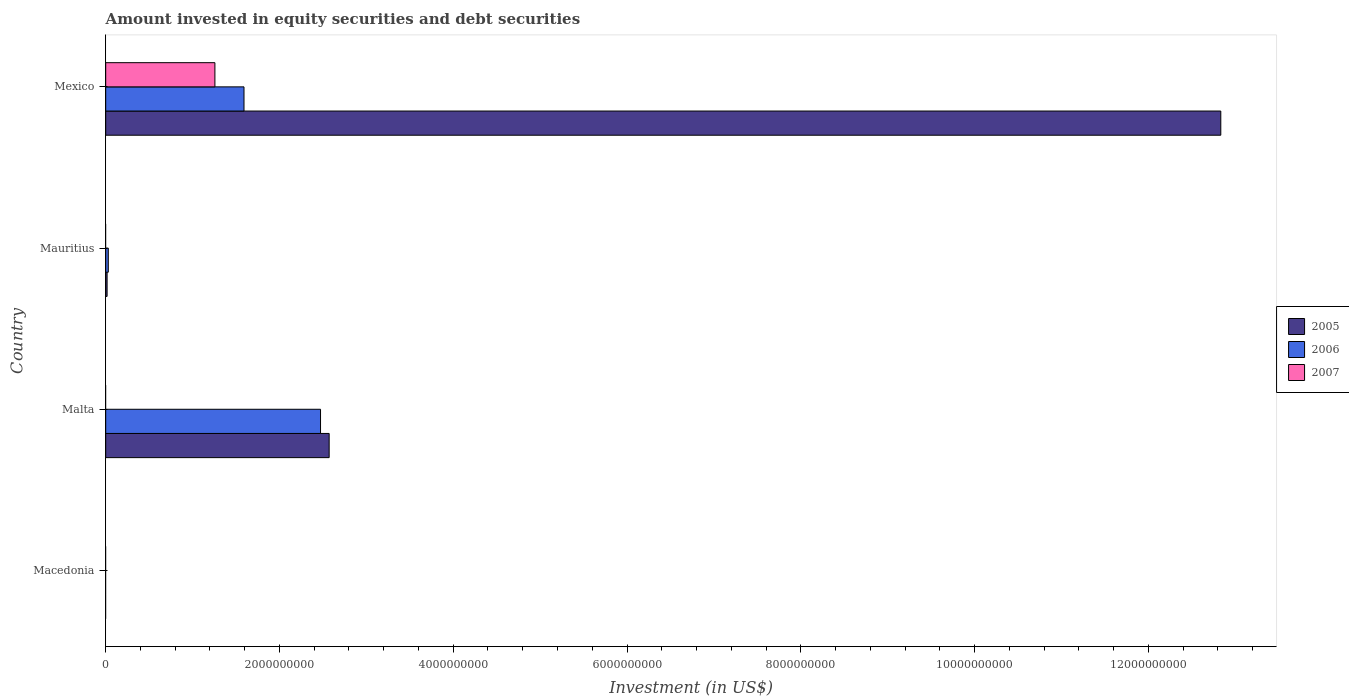Are the number of bars per tick equal to the number of legend labels?
Your response must be concise. No. Are the number of bars on each tick of the Y-axis equal?
Offer a terse response. No. How many bars are there on the 4th tick from the bottom?
Keep it short and to the point. 3. What is the label of the 4th group of bars from the top?
Offer a very short reply. Macedonia. What is the amount invested in equity securities and debt securities in 2007 in Mauritius?
Give a very brief answer. 0. Across all countries, what is the maximum amount invested in equity securities and debt securities in 2005?
Your response must be concise. 1.28e+1. In which country was the amount invested in equity securities and debt securities in 2007 maximum?
Your answer should be very brief. Mexico. What is the total amount invested in equity securities and debt securities in 2005 in the graph?
Ensure brevity in your answer.  1.54e+1. What is the difference between the amount invested in equity securities and debt securities in 2005 in Mauritius and that in Mexico?
Offer a very short reply. -1.28e+1. What is the difference between the amount invested in equity securities and debt securities in 2007 in Mauritius and the amount invested in equity securities and debt securities in 2006 in Macedonia?
Provide a short and direct response. 0. What is the average amount invested in equity securities and debt securities in 2007 per country?
Your response must be concise. 3.14e+08. What is the ratio of the amount invested in equity securities and debt securities in 2005 in Malta to that in Mexico?
Provide a short and direct response. 0.2. What is the difference between the highest and the second highest amount invested in equity securities and debt securities in 2006?
Ensure brevity in your answer.  8.81e+08. What is the difference between the highest and the lowest amount invested in equity securities and debt securities in 2006?
Give a very brief answer. 2.47e+09. In how many countries, is the amount invested in equity securities and debt securities in 2006 greater than the average amount invested in equity securities and debt securities in 2006 taken over all countries?
Provide a short and direct response. 2. Is the sum of the amount invested in equity securities and debt securities in 2006 in Malta and Mexico greater than the maximum amount invested in equity securities and debt securities in 2007 across all countries?
Keep it short and to the point. Yes. Is it the case that in every country, the sum of the amount invested in equity securities and debt securities in 2007 and amount invested in equity securities and debt securities in 2005 is greater than the amount invested in equity securities and debt securities in 2006?
Give a very brief answer. No. How many countries are there in the graph?
Make the answer very short. 4. What is the difference between two consecutive major ticks on the X-axis?
Offer a terse response. 2.00e+09. Are the values on the major ticks of X-axis written in scientific E-notation?
Your response must be concise. No. Does the graph contain any zero values?
Provide a succinct answer. Yes. How are the legend labels stacked?
Provide a succinct answer. Vertical. What is the title of the graph?
Your answer should be very brief. Amount invested in equity securities and debt securities. What is the label or title of the X-axis?
Provide a short and direct response. Investment (in US$). What is the Investment (in US$) of 2005 in Macedonia?
Your answer should be compact. 0. What is the Investment (in US$) of 2006 in Macedonia?
Ensure brevity in your answer.  0. What is the Investment (in US$) in 2007 in Macedonia?
Your response must be concise. 0. What is the Investment (in US$) in 2005 in Malta?
Ensure brevity in your answer.  2.57e+09. What is the Investment (in US$) of 2006 in Malta?
Offer a very short reply. 2.47e+09. What is the Investment (in US$) in 2007 in Malta?
Provide a succinct answer. 0. What is the Investment (in US$) in 2005 in Mauritius?
Your answer should be compact. 1.62e+07. What is the Investment (in US$) in 2006 in Mauritius?
Your answer should be compact. 2.99e+07. What is the Investment (in US$) in 2005 in Mexico?
Your answer should be compact. 1.28e+1. What is the Investment (in US$) in 2006 in Mexico?
Your answer should be very brief. 1.59e+09. What is the Investment (in US$) of 2007 in Mexico?
Ensure brevity in your answer.  1.26e+09. Across all countries, what is the maximum Investment (in US$) of 2005?
Provide a short and direct response. 1.28e+1. Across all countries, what is the maximum Investment (in US$) in 2006?
Provide a succinct answer. 2.47e+09. Across all countries, what is the maximum Investment (in US$) of 2007?
Your answer should be compact. 1.26e+09. Across all countries, what is the minimum Investment (in US$) in 2006?
Provide a short and direct response. 0. Across all countries, what is the minimum Investment (in US$) in 2007?
Your response must be concise. 0. What is the total Investment (in US$) in 2005 in the graph?
Your answer should be very brief. 1.54e+1. What is the total Investment (in US$) in 2006 in the graph?
Ensure brevity in your answer.  4.09e+09. What is the total Investment (in US$) in 2007 in the graph?
Ensure brevity in your answer.  1.26e+09. What is the difference between the Investment (in US$) of 2005 in Malta and that in Mauritius?
Provide a short and direct response. 2.56e+09. What is the difference between the Investment (in US$) of 2006 in Malta and that in Mauritius?
Ensure brevity in your answer.  2.44e+09. What is the difference between the Investment (in US$) in 2005 in Malta and that in Mexico?
Your answer should be compact. -1.03e+1. What is the difference between the Investment (in US$) in 2006 in Malta and that in Mexico?
Make the answer very short. 8.81e+08. What is the difference between the Investment (in US$) in 2005 in Mauritius and that in Mexico?
Provide a short and direct response. -1.28e+1. What is the difference between the Investment (in US$) in 2006 in Mauritius and that in Mexico?
Provide a succinct answer. -1.56e+09. What is the difference between the Investment (in US$) of 2005 in Malta and the Investment (in US$) of 2006 in Mauritius?
Offer a terse response. 2.54e+09. What is the difference between the Investment (in US$) of 2005 in Malta and the Investment (in US$) of 2006 in Mexico?
Make the answer very short. 9.80e+08. What is the difference between the Investment (in US$) in 2005 in Malta and the Investment (in US$) in 2007 in Mexico?
Give a very brief answer. 1.32e+09. What is the difference between the Investment (in US$) in 2006 in Malta and the Investment (in US$) in 2007 in Mexico?
Offer a very short reply. 1.22e+09. What is the difference between the Investment (in US$) of 2005 in Mauritius and the Investment (in US$) of 2006 in Mexico?
Ensure brevity in your answer.  -1.58e+09. What is the difference between the Investment (in US$) in 2005 in Mauritius and the Investment (in US$) in 2007 in Mexico?
Offer a terse response. -1.24e+09. What is the difference between the Investment (in US$) in 2006 in Mauritius and the Investment (in US$) in 2007 in Mexico?
Your answer should be very brief. -1.23e+09. What is the average Investment (in US$) of 2005 per country?
Offer a very short reply. 3.86e+09. What is the average Investment (in US$) of 2006 per country?
Make the answer very short. 1.02e+09. What is the average Investment (in US$) in 2007 per country?
Offer a terse response. 3.14e+08. What is the difference between the Investment (in US$) in 2005 and Investment (in US$) in 2006 in Malta?
Your answer should be compact. 9.93e+07. What is the difference between the Investment (in US$) of 2005 and Investment (in US$) of 2006 in Mauritius?
Keep it short and to the point. -1.38e+07. What is the difference between the Investment (in US$) of 2005 and Investment (in US$) of 2006 in Mexico?
Offer a very short reply. 1.12e+1. What is the difference between the Investment (in US$) in 2005 and Investment (in US$) in 2007 in Mexico?
Your answer should be compact. 1.16e+1. What is the difference between the Investment (in US$) in 2006 and Investment (in US$) in 2007 in Mexico?
Your response must be concise. 3.35e+08. What is the ratio of the Investment (in US$) of 2005 in Malta to that in Mauritius?
Offer a very short reply. 159.21. What is the ratio of the Investment (in US$) in 2006 in Malta to that in Mauritius?
Offer a very short reply. 82.62. What is the ratio of the Investment (in US$) in 2005 in Malta to that in Mexico?
Ensure brevity in your answer.  0.2. What is the ratio of the Investment (in US$) of 2006 in Malta to that in Mexico?
Give a very brief answer. 1.55. What is the ratio of the Investment (in US$) in 2005 in Mauritius to that in Mexico?
Give a very brief answer. 0. What is the ratio of the Investment (in US$) of 2006 in Mauritius to that in Mexico?
Give a very brief answer. 0.02. What is the difference between the highest and the second highest Investment (in US$) of 2005?
Make the answer very short. 1.03e+1. What is the difference between the highest and the second highest Investment (in US$) in 2006?
Keep it short and to the point. 8.81e+08. What is the difference between the highest and the lowest Investment (in US$) in 2005?
Provide a succinct answer. 1.28e+1. What is the difference between the highest and the lowest Investment (in US$) of 2006?
Provide a short and direct response. 2.47e+09. What is the difference between the highest and the lowest Investment (in US$) of 2007?
Provide a succinct answer. 1.26e+09. 